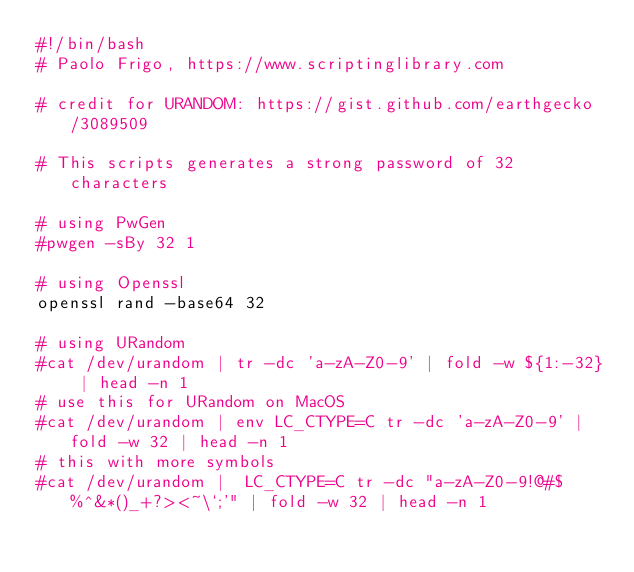<code> <loc_0><loc_0><loc_500><loc_500><_Bash_>#!/bin/bash
# Paolo Frigo, https://www.scriptinglibrary.com

# credit for URANDOM: https://gist.github.com/earthgecko/3089509

# This scripts generates a strong password of 32 characters

# using PwGen 
#pwgen -sBy 32 1

# using Openssl
openssl rand -base64 32

# using URandom 
#cat /dev/urandom | tr -dc 'a-zA-Z0-9' | fold -w ${1:-32} | head -n 1
# use this for URandom on MacOS
#cat /dev/urandom | env LC_CTYPE=C tr -dc 'a-zA-Z0-9' | fold -w 32 | head -n 1
# this with more symbols
#cat /dev/urandom |  LC_CTYPE=C tr -dc "a-zA-Z0-9!@#$%^&*()_+?><~\`;'" | fold -w 32 | head -n 1
</code> 